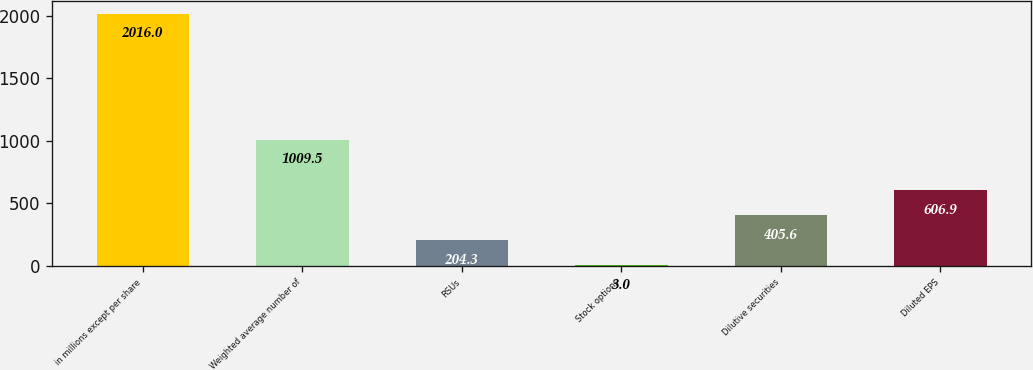<chart> <loc_0><loc_0><loc_500><loc_500><bar_chart><fcel>in millions except per share<fcel>Weighted average number of<fcel>RSUs<fcel>Stock options<fcel>Dilutive securities<fcel>Diluted EPS<nl><fcel>2016<fcel>1009.5<fcel>204.3<fcel>3<fcel>405.6<fcel>606.9<nl></chart> 